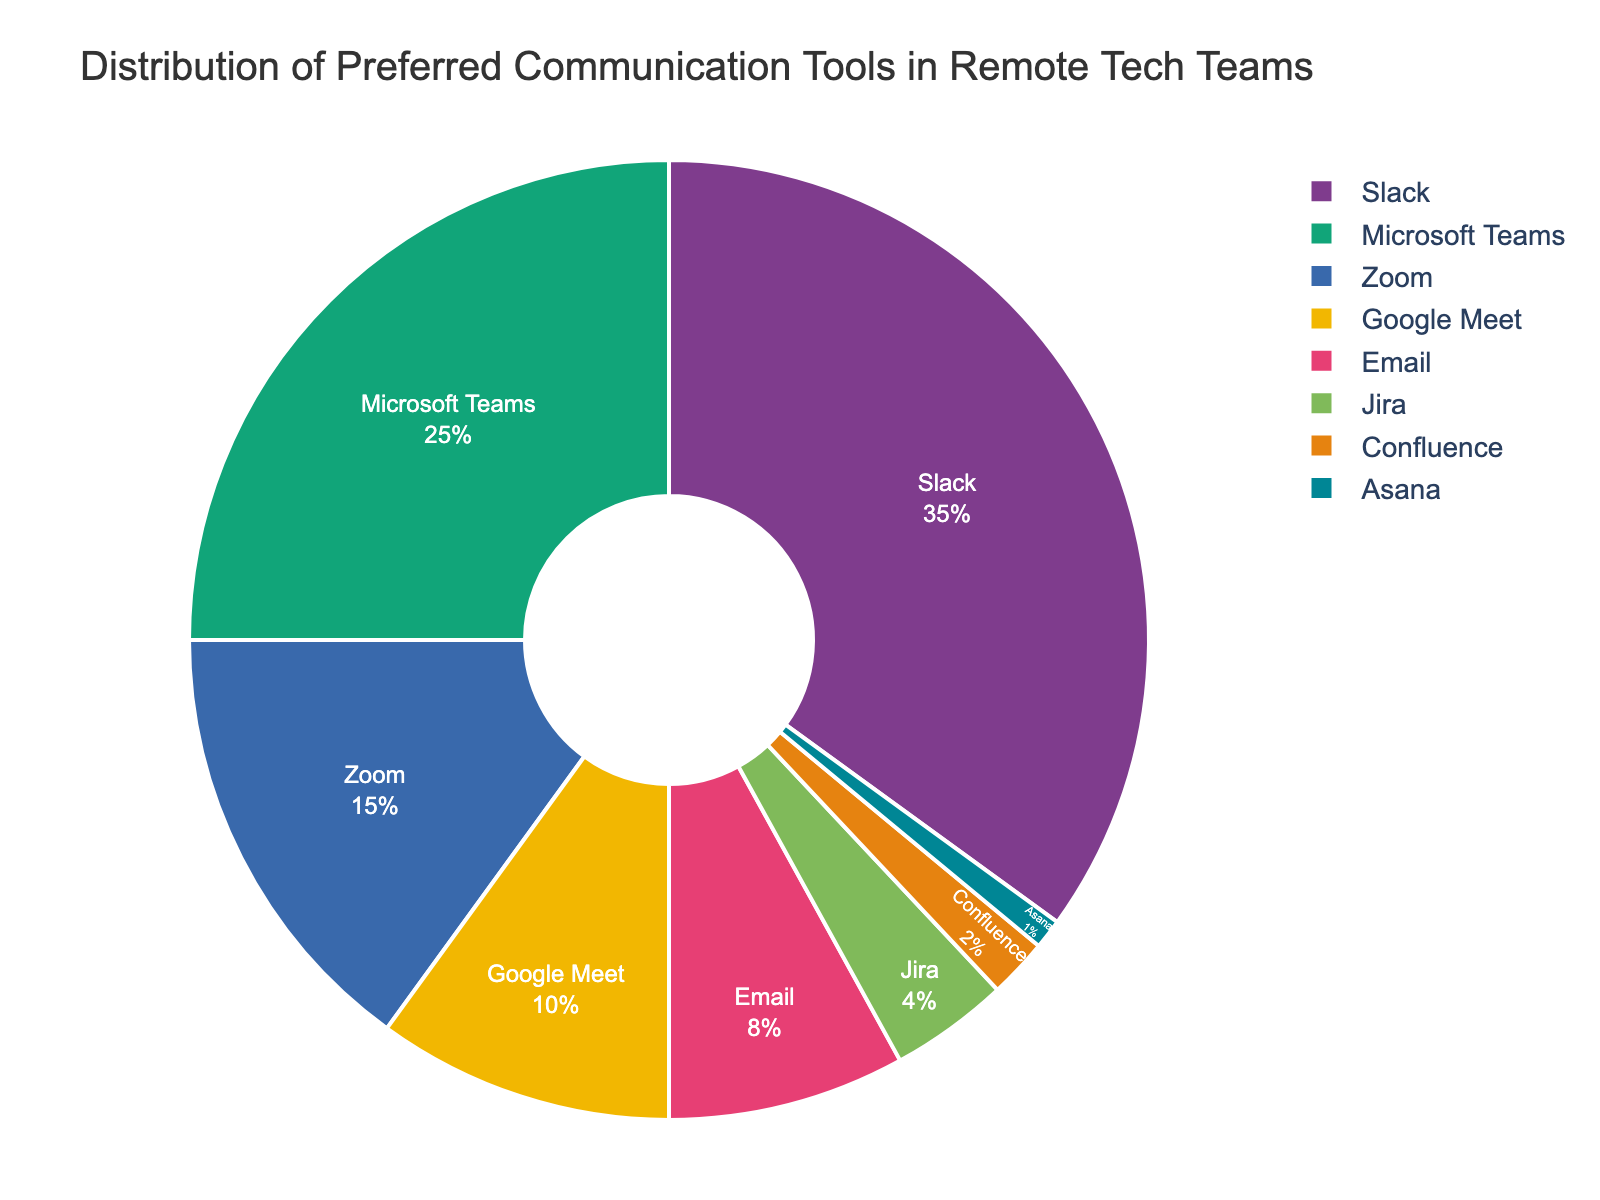What is the most preferred communication tool? The chart shows that Slack has the largest percentage of preference, represented by the largest segment.
Answer: Slack What is the combined percentage of teams preferring Zoom and Google Meet? The chart shows Zoom at 15% and Google Meet at 10%. Adding these together: 15% + 10% = 25%
Answer: 25% Which communication tool is less preferred: Email or Microsoft Teams? The chart shows Email at 8% and Microsoft Teams at 25%. 8% is less than 25%.
Answer: Email How much more preferred is Slack compared to Zoom? Slack has 35% preference and Zoom has 15%. Subtracting these: 35% - 15% = 20%
Answer: 20% What is the combined preference for project management tools (Jira, Confluence, and Asana)? Adding the percentages: Jira (4%) + Confluence (2%) + Asana (1%) = 4% + 2% + 1% = 7%
Answer: 7% Which tool has the smallest representation in the chart? The chart shows Asana as the smallest segment with 1%.
Answer: Asana Is Microsoft Teams or Google Meet more preferred? Microsoft Teams has a preference of 25% while Google Meet has 10%. 25% is greater than 10%.
Answer: Microsoft Teams Which tools have a preference greater than 20%? Slack (35%) and Microsoft Teams (25%) both have preference percentages greater than 20%.
Answer: Slack and Microsoft Teams What percentage of teams prefer Email, Jira, and Confluence combined? Adding the percentages: Email (8%) + Jira (4%) + Confluence (2%) = 8% + 4% + 2% = 14%
Answer: 14% Compare the total preference for Microsoft Teams and Email to the total preference for Zoom and Google Meet? Microsoft Teams and Email combined: 25% + 8% = 33%. Zoom and Google Meet combined: 15% + 10% = 25%. 33% is greater than 25%.
Answer: Microsoft Teams and Email 